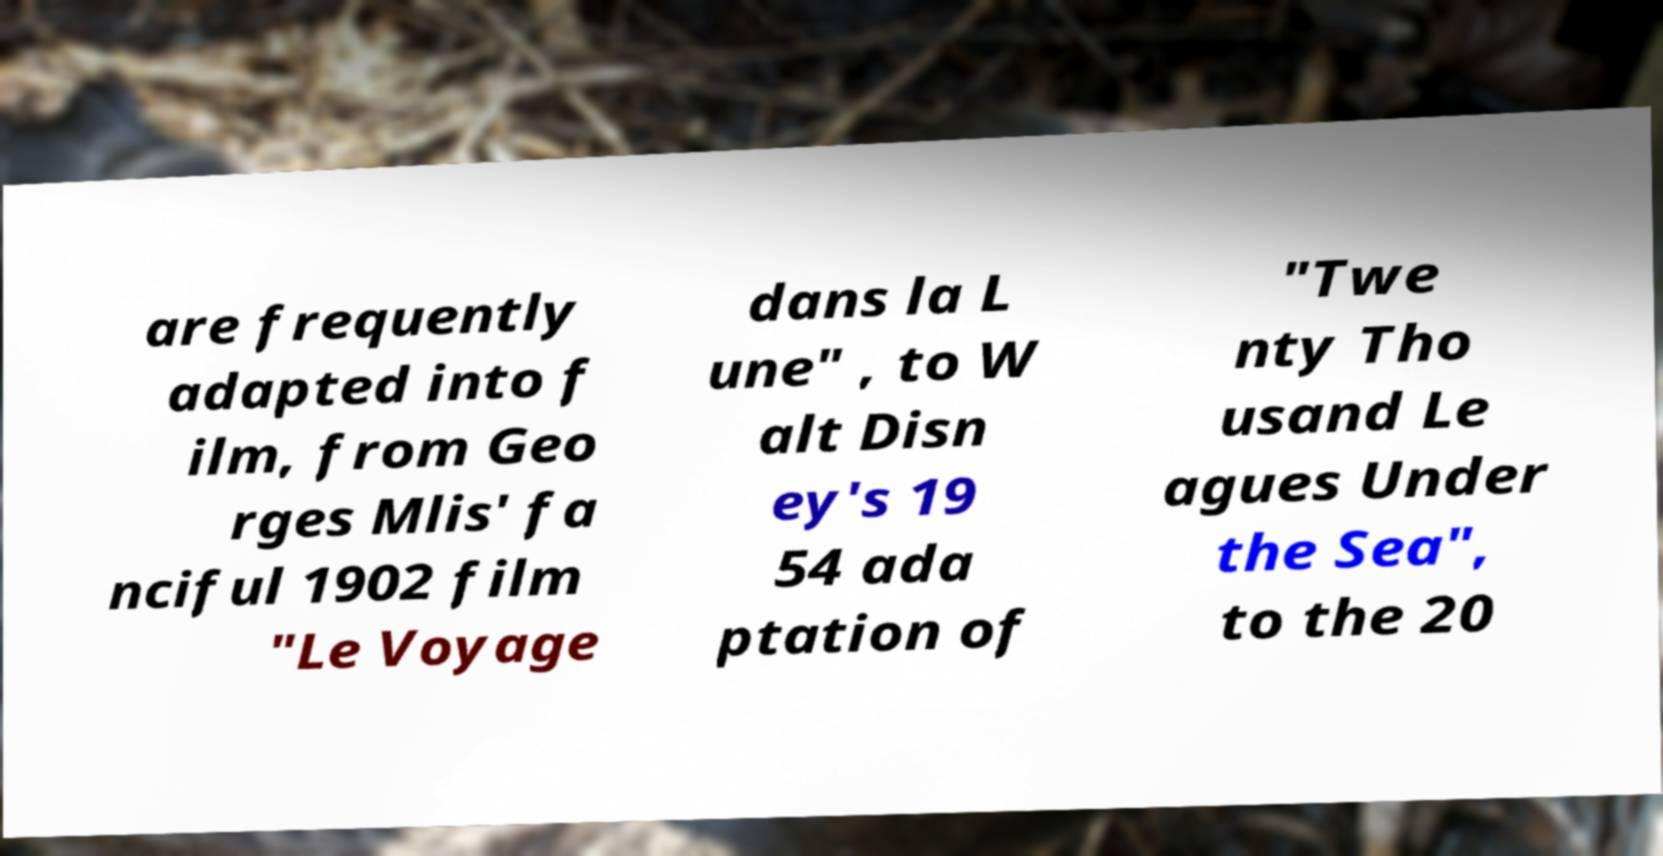For documentation purposes, I need the text within this image transcribed. Could you provide that? are frequently adapted into f ilm, from Geo rges Mlis' fa nciful 1902 film "Le Voyage dans la L une" , to W alt Disn ey's 19 54 ada ptation of "Twe nty Tho usand Le agues Under the Sea", to the 20 